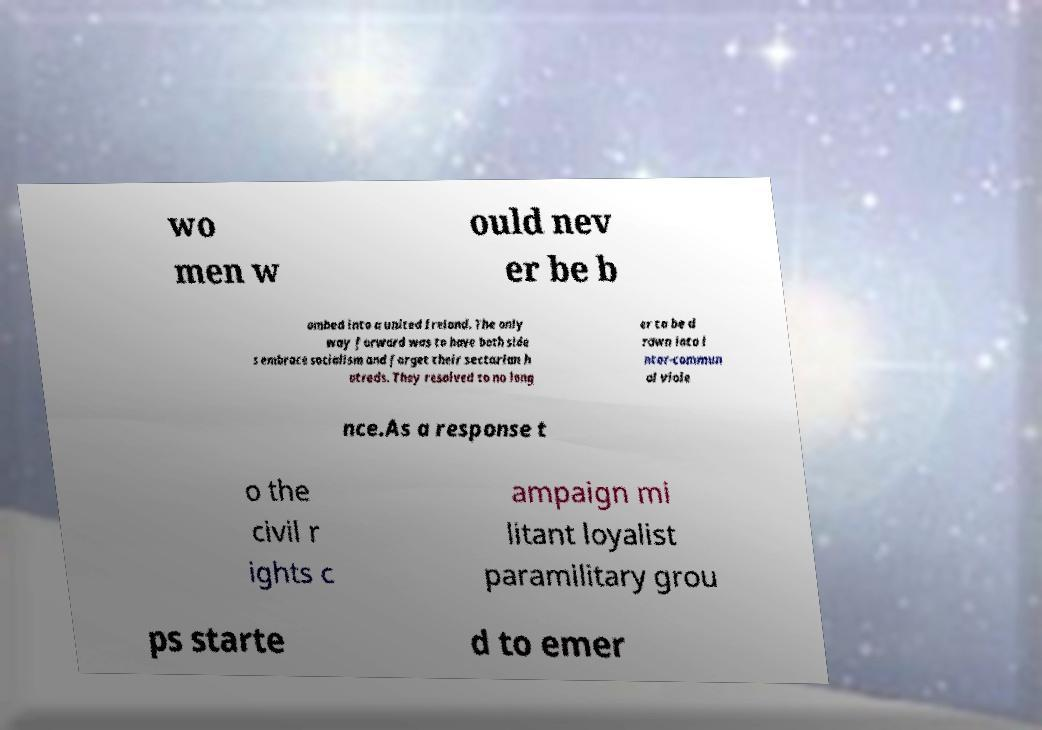I need the written content from this picture converted into text. Can you do that? wo men w ould nev er be b ombed into a united Ireland. The only way forward was to have both side s embrace socialism and forget their sectarian h atreds. They resolved to no long er to be d rawn into i nter-commun al viole nce.As a response t o the civil r ights c ampaign mi litant loyalist paramilitary grou ps starte d to emer 